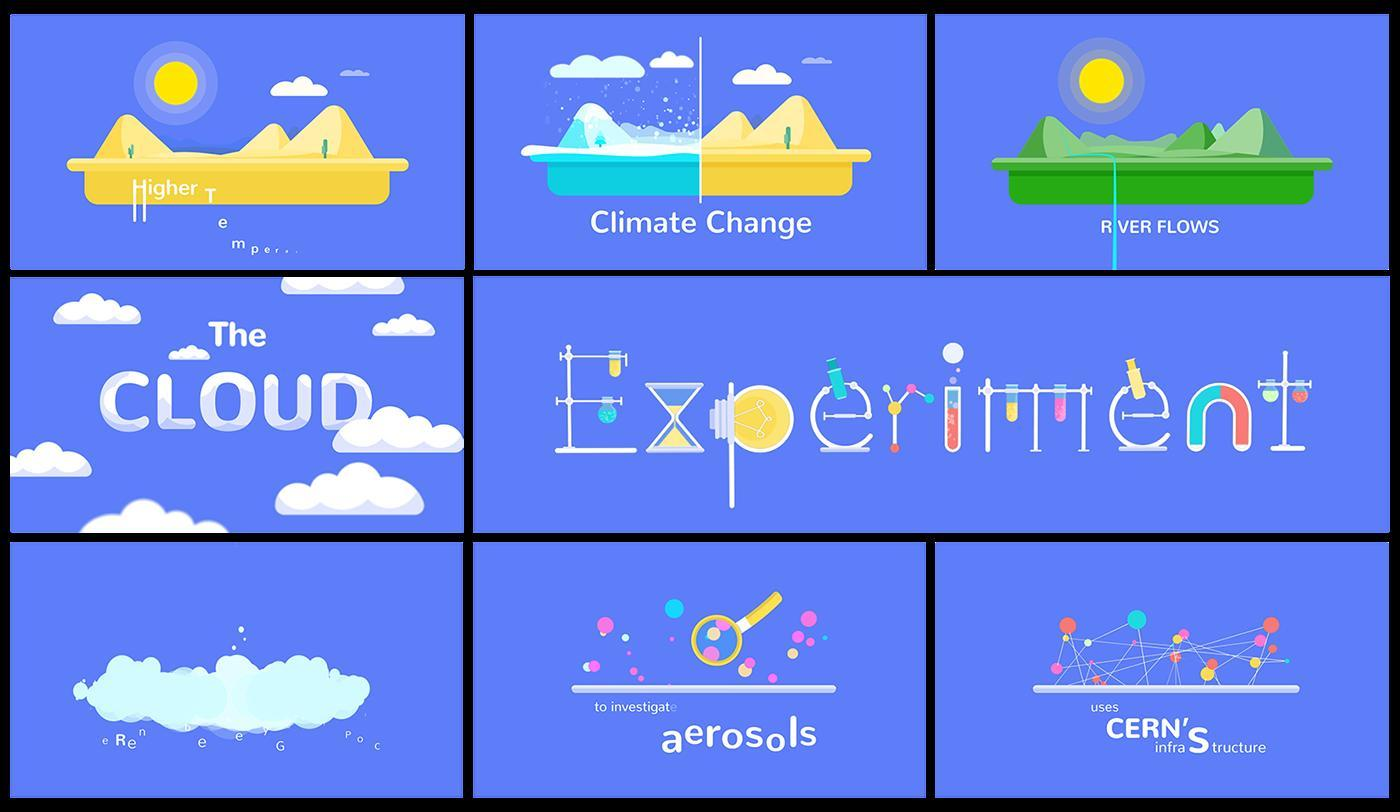What is the colour of ice in climate change , yellow or blue
Answer the question with a short phrase. blue test tubes and light bulbs are shown in which word experiment 